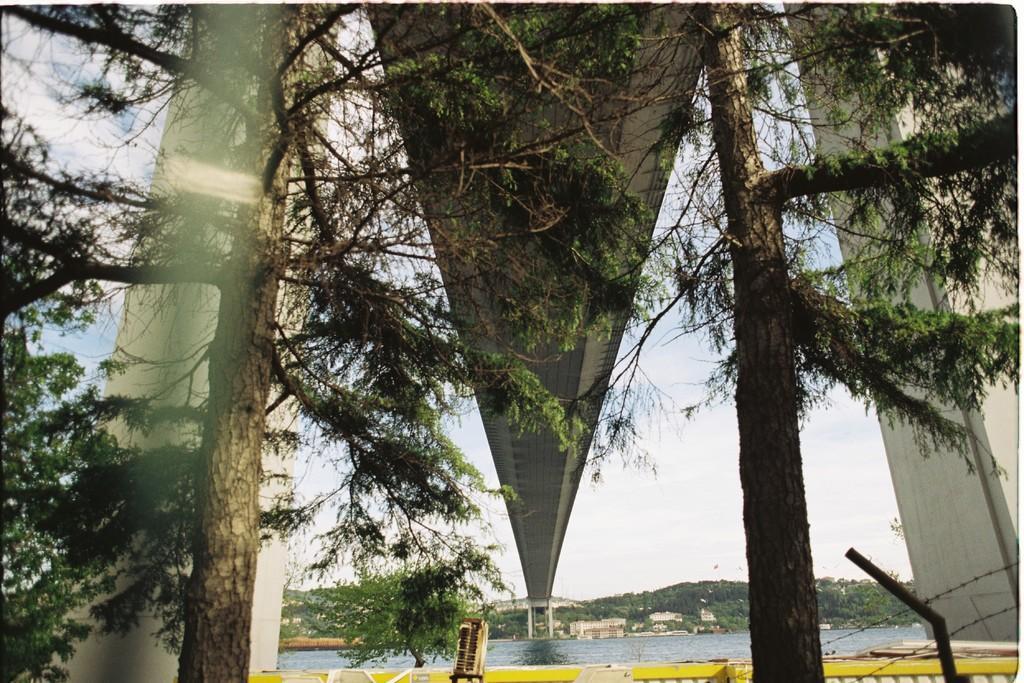Can you describe this image briefly? In this image we can see bridge, trees, sky, clouds, hills and water. 